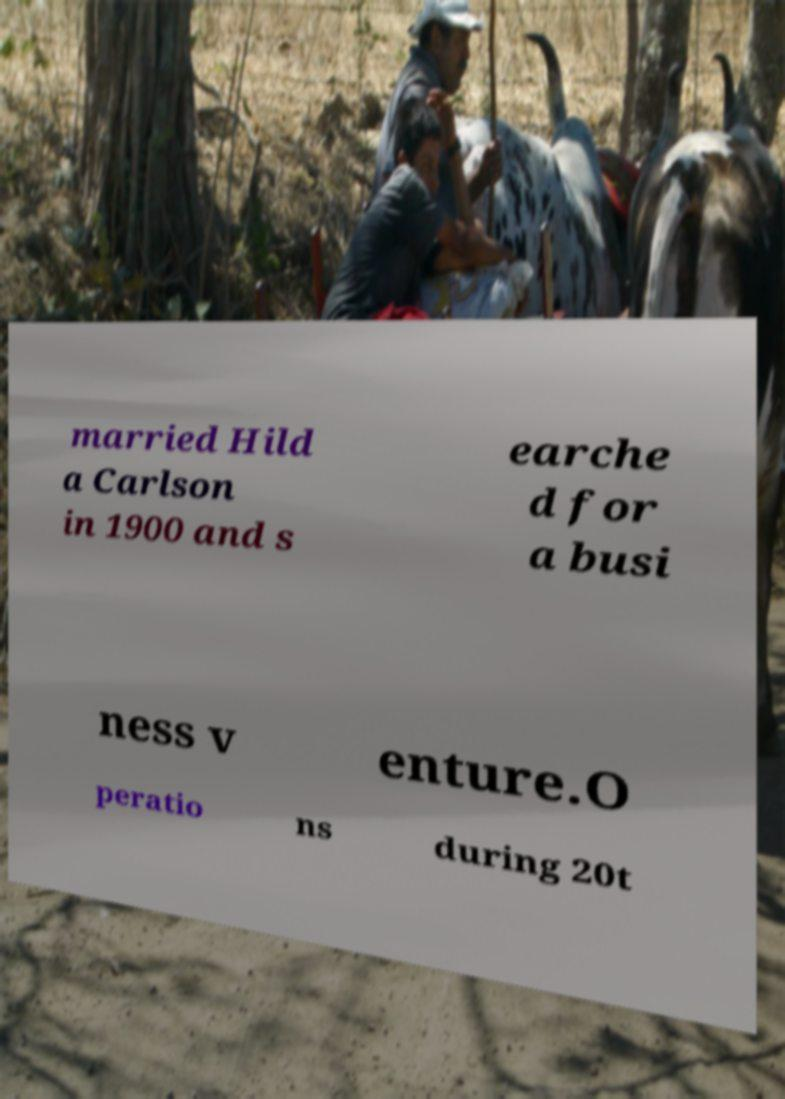What messages or text are displayed in this image? I need them in a readable, typed format. married Hild a Carlson in 1900 and s earche d for a busi ness v enture.O peratio ns during 20t 